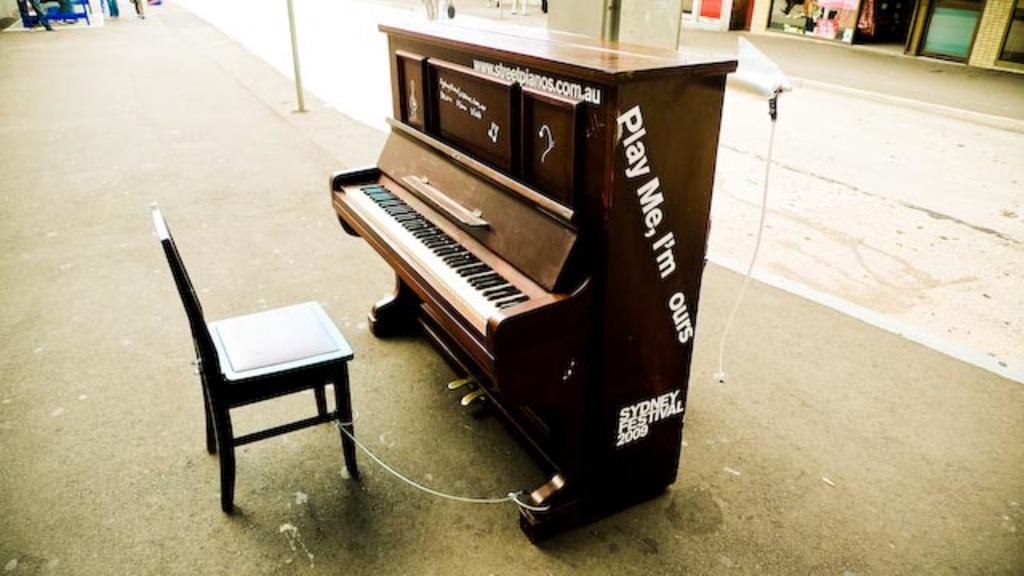Please provide a concise description of this image. There is a chair and antique wooden piano on road behind a building. 